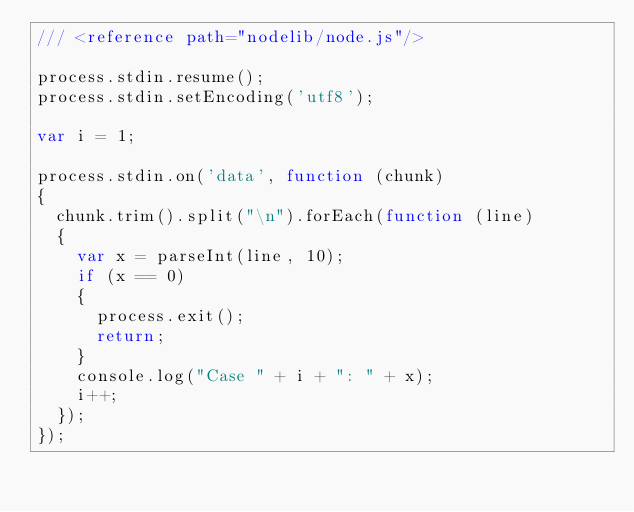Convert code to text. <code><loc_0><loc_0><loc_500><loc_500><_JavaScript_>/// <reference path="nodelib/node.js"/>

process.stdin.resume();
process.stdin.setEncoding('utf8');

var i = 1;

process.stdin.on('data', function (chunk)
{
	chunk.trim().split("\n").forEach(function (line)
	{
		var x = parseInt(line, 10);
		if (x == 0)
		{
			process.exit();
			return;
		}
		console.log("Case " + i + ": " + x);
		i++;
	});
});</code> 